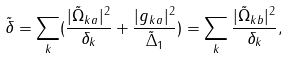Convert formula to latex. <formula><loc_0><loc_0><loc_500><loc_500>\tilde { \delta } = \sum _ { k } ( \frac { | \tilde { \Omega } _ { k a } | ^ { 2 } } { \delta _ { k } } + \frac { | g _ { k a } | ^ { 2 } } { \tilde { \Delta } _ { 1 } } ) = \sum _ { k } \frac { | \tilde { \Omega } _ { k b } | ^ { 2 } } { \delta _ { k } } ,</formula> 